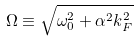Convert formula to latex. <formula><loc_0><loc_0><loc_500><loc_500>\Omega \equiv \sqrt { \omega _ { 0 } ^ { 2 } + \alpha ^ { 2 } k _ { F } ^ { 2 } }</formula> 